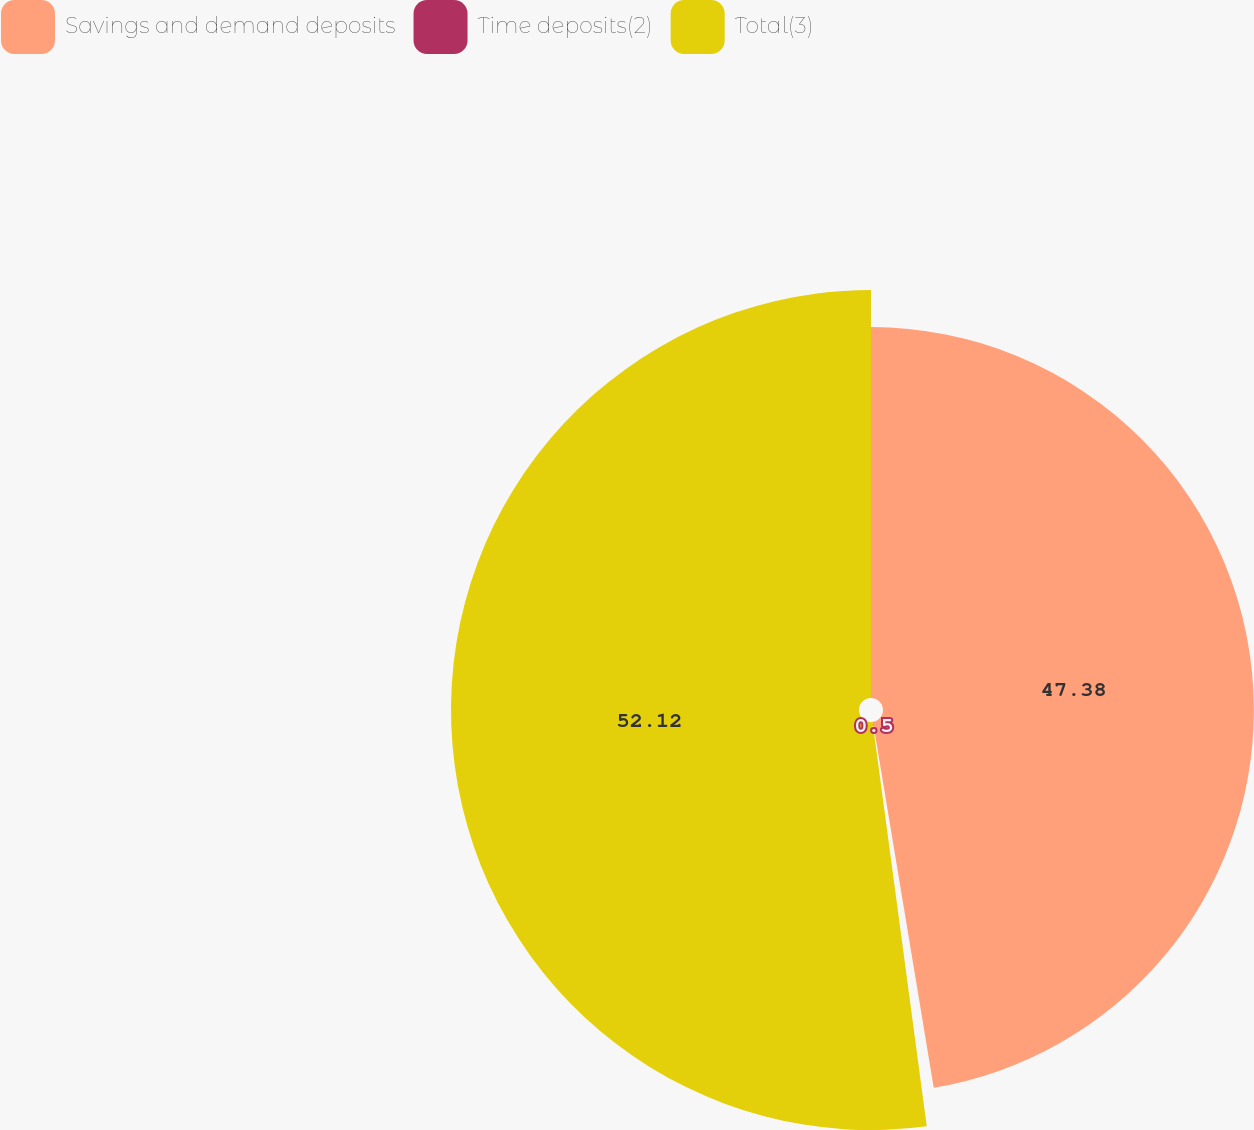Convert chart. <chart><loc_0><loc_0><loc_500><loc_500><pie_chart><fcel>Savings and demand deposits<fcel>Time deposits(2)<fcel>Total(3)<nl><fcel>47.38%<fcel>0.5%<fcel>52.12%<nl></chart> 